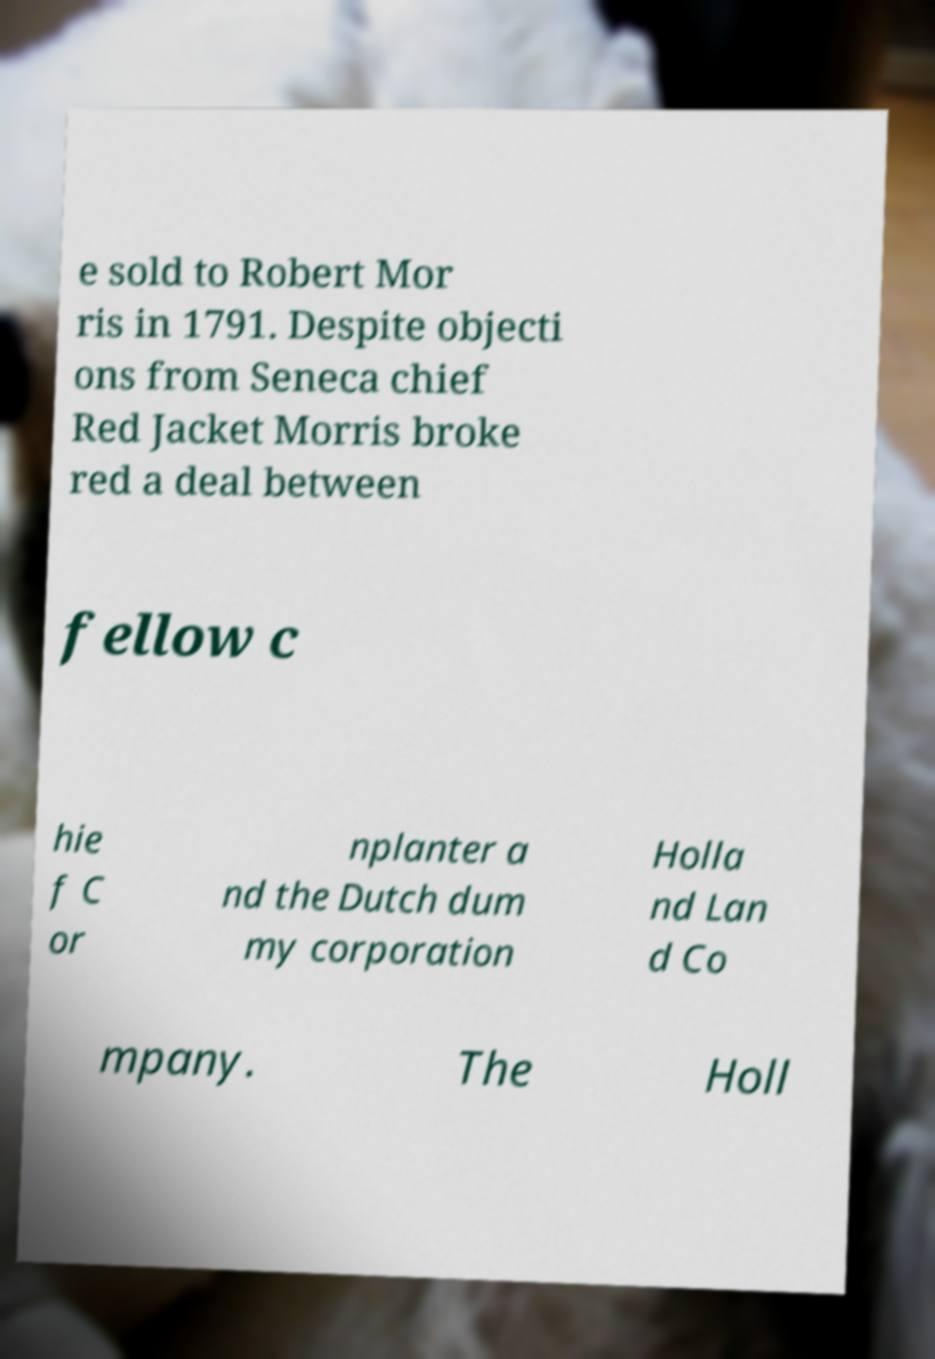I need the written content from this picture converted into text. Can you do that? e sold to Robert Mor ris in 1791. Despite objecti ons from Seneca chief Red Jacket Morris broke red a deal between fellow c hie f C or nplanter a nd the Dutch dum my corporation Holla nd Lan d Co mpany. The Holl 